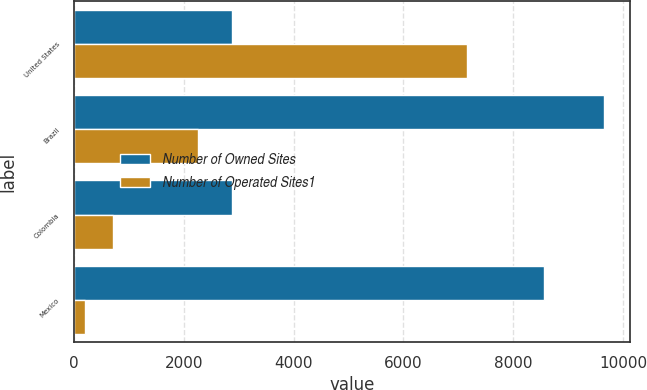<chart> <loc_0><loc_0><loc_500><loc_500><stacked_bar_chart><ecel><fcel>United States<fcel>Brazil<fcel>Colombia<fcel>Mexico<nl><fcel>Number of Owned Sites<fcel>2884<fcel>9642<fcel>2884<fcel>8551<nl><fcel>Number of Operated Sites1<fcel>7164<fcel>2268<fcel>706<fcel>199<nl></chart> 